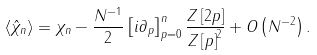<formula> <loc_0><loc_0><loc_500><loc_500>\left \langle \hat { \chi } _ { n } \right \rangle = \chi _ { n } - \frac { N ^ { - 1 } } { 2 } \left [ i \partial _ { p } \right ] _ { p = 0 } ^ { n } \frac { Z \left [ 2 p \right ] } { Z \left [ p \right ] ^ { 2 } } + O \left ( N ^ { - 2 } \right ) .</formula> 